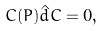<formula> <loc_0><loc_0><loc_500><loc_500>C ( P ) \hat { d } C = 0 ,</formula> 